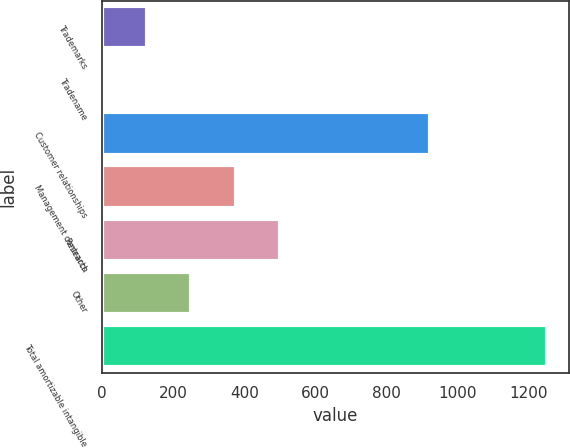<chart> <loc_0><loc_0><loc_500><loc_500><bar_chart><fcel>Trademarks<fcel>Tradename<fcel>Customer relationships<fcel>Management contracts<fcel>Research<fcel>Other<fcel>Total amortizable intangible<nl><fcel>126.8<fcel>2<fcel>923<fcel>376.4<fcel>501.2<fcel>251.6<fcel>1250<nl></chart> 